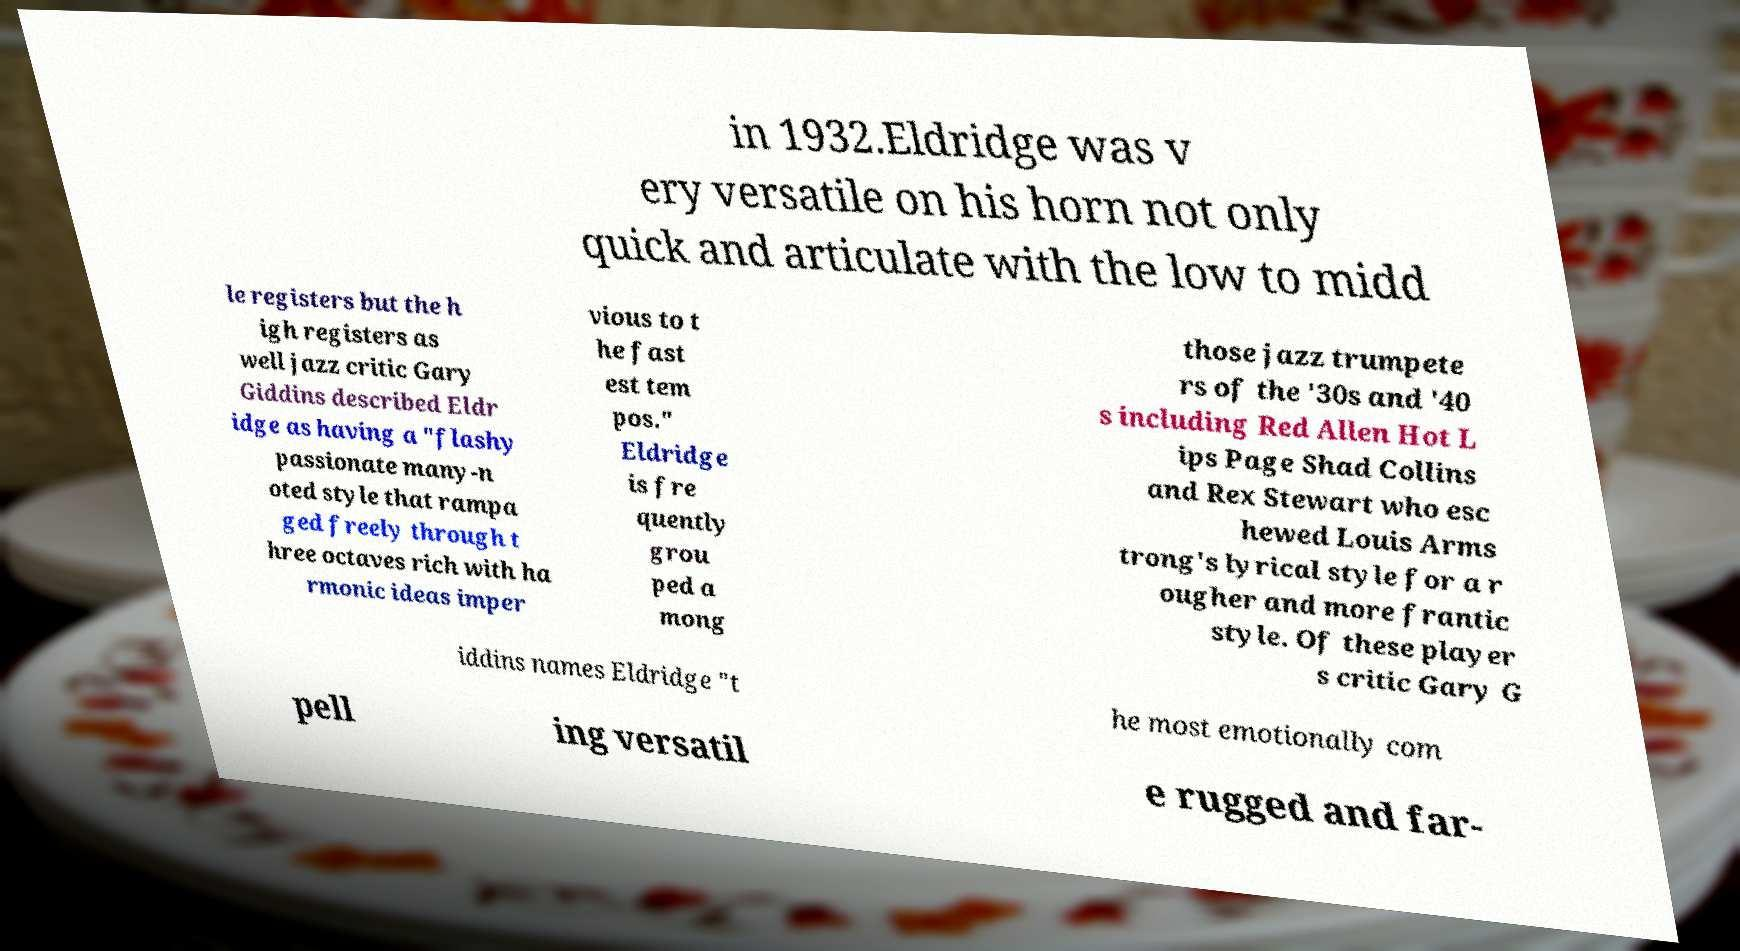Can you read and provide the text displayed in the image?This photo seems to have some interesting text. Can you extract and type it out for me? in 1932.Eldridge was v ery versatile on his horn not only quick and articulate with the low to midd le registers but the h igh registers as well jazz critic Gary Giddins described Eldr idge as having a "flashy passionate many-n oted style that rampa ged freely through t hree octaves rich with ha rmonic ideas imper vious to t he fast est tem pos." Eldridge is fre quently grou ped a mong those jazz trumpete rs of the '30s and '40 s including Red Allen Hot L ips Page Shad Collins and Rex Stewart who esc hewed Louis Arms trong's lyrical style for a r ougher and more frantic style. Of these player s critic Gary G iddins names Eldridge "t he most emotionally com pell ing versatil e rugged and far- 